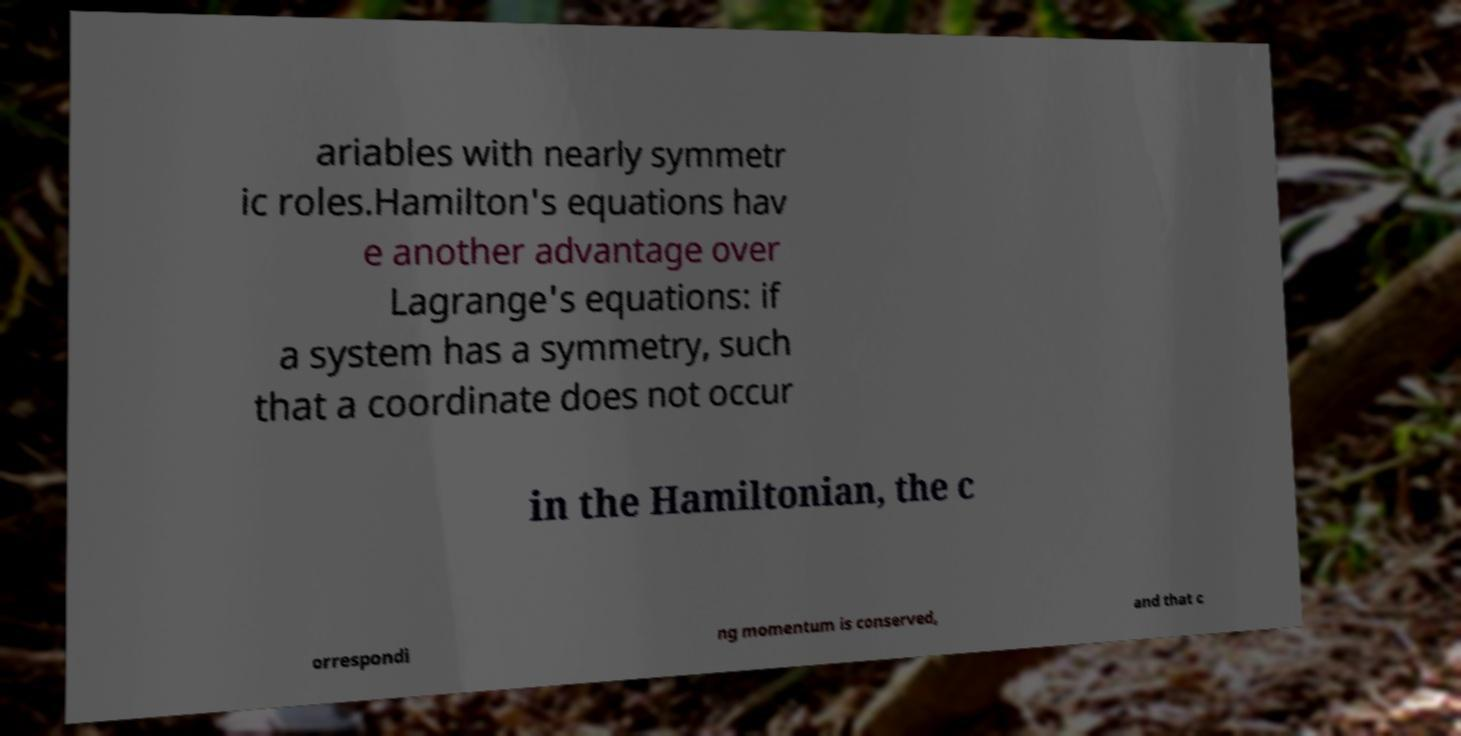Can you read and provide the text displayed in the image?This photo seems to have some interesting text. Can you extract and type it out for me? ariables with nearly symmetr ic roles.Hamilton's equations hav e another advantage over Lagrange's equations: if a system has a symmetry, such that a coordinate does not occur in the Hamiltonian, the c orrespondi ng momentum is conserved, and that c 